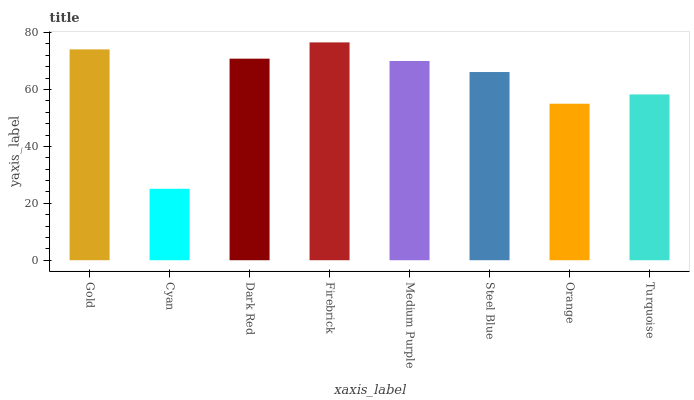Is Cyan the minimum?
Answer yes or no. Yes. Is Firebrick the maximum?
Answer yes or no. Yes. Is Dark Red the minimum?
Answer yes or no. No. Is Dark Red the maximum?
Answer yes or no. No. Is Dark Red greater than Cyan?
Answer yes or no. Yes. Is Cyan less than Dark Red?
Answer yes or no. Yes. Is Cyan greater than Dark Red?
Answer yes or no. No. Is Dark Red less than Cyan?
Answer yes or no. No. Is Medium Purple the high median?
Answer yes or no. Yes. Is Steel Blue the low median?
Answer yes or no. Yes. Is Turquoise the high median?
Answer yes or no. No. Is Orange the low median?
Answer yes or no. No. 